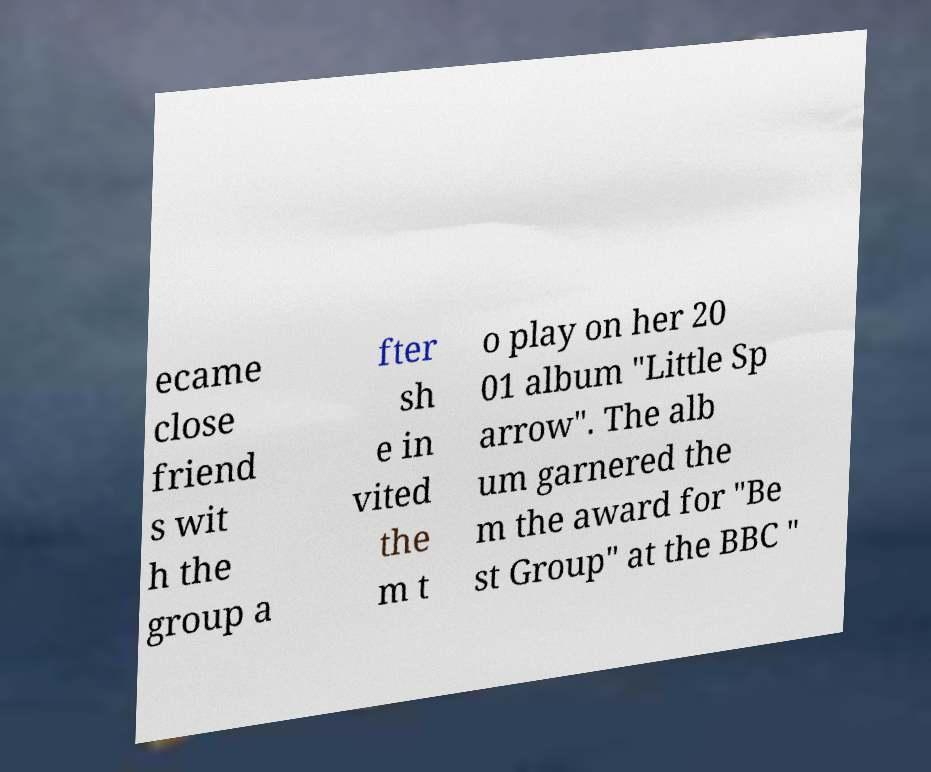Can you accurately transcribe the text from the provided image for me? ecame close friend s wit h the group a fter sh e in vited the m t o play on her 20 01 album "Little Sp arrow". The alb um garnered the m the award for "Be st Group" at the BBC " 